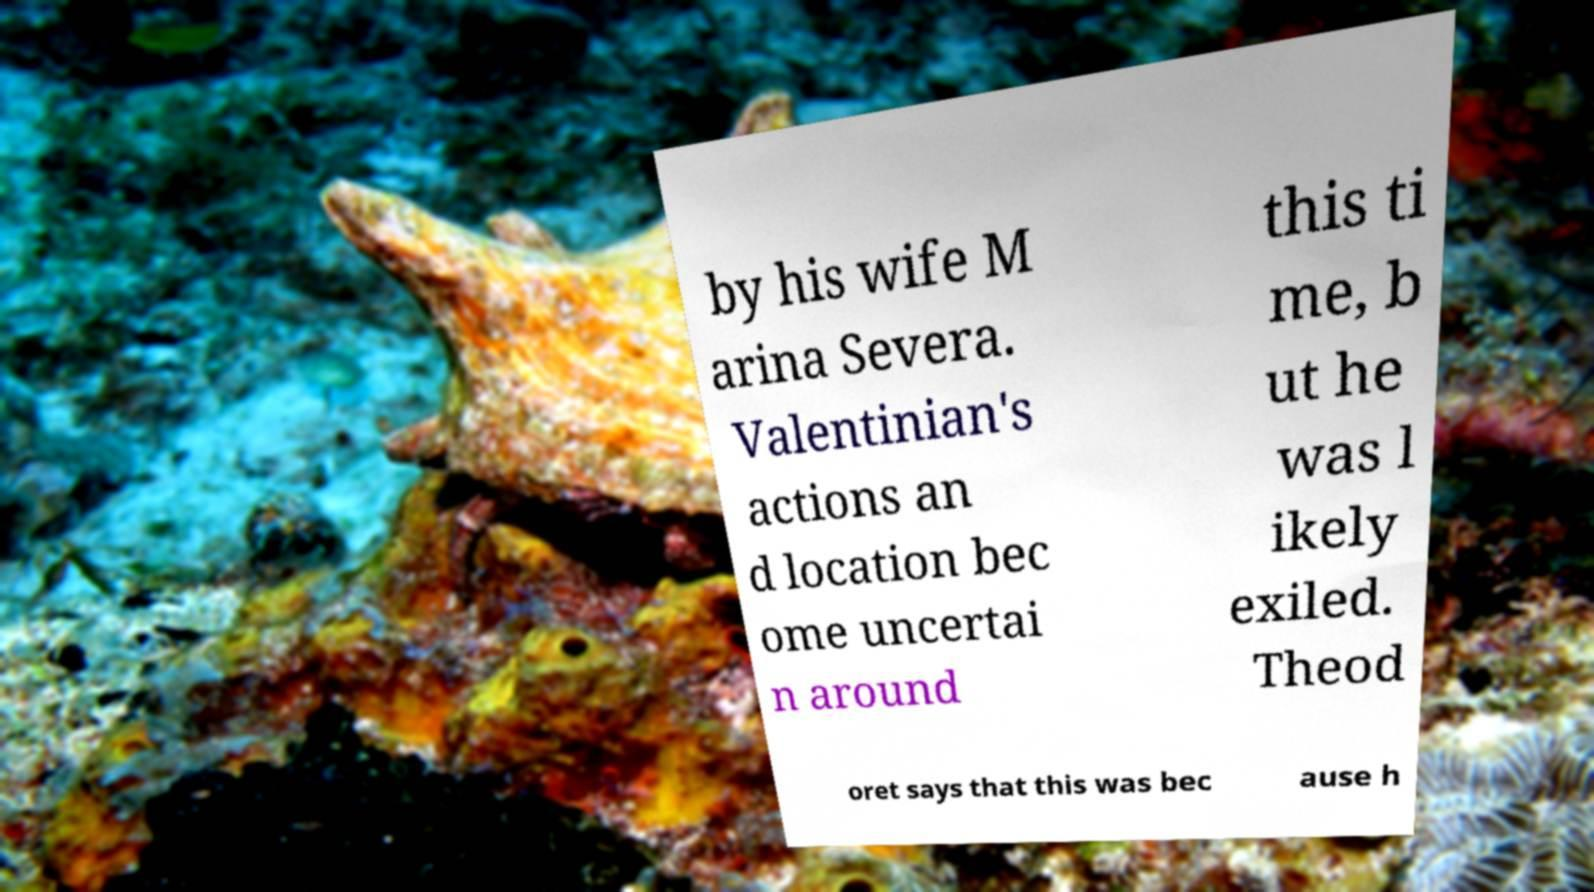Can you read and provide the text displayed in the image?This photo seems to have some interesting text. Can you extract and type it out for me? by his wife M arina Severa. Valentinian's actions an d location bec ome uncertai n around this ti me, b ut he was l ikely exiled. Theod oret says that this was bec ause h 